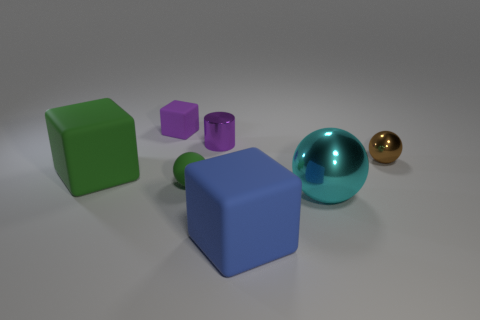Add 3 rubber balls. How many objects exist? 10 Subtract all cylinders. How many objects are left? 6 Add 6 cyan shiny things. How many cyan shiny things are left? 7 Add 1 red matte cylinders. How many red matte cylinders exist? 1 Subtract 0 yellow cubes. How many objects are left? 7 Subtract all small green matte cubes. Subtract all cyan things. How many objects are left? 6 